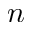Convert formula to latex. <formula><loc_0><loc_0><loc_500><loc_500>n</formula> 